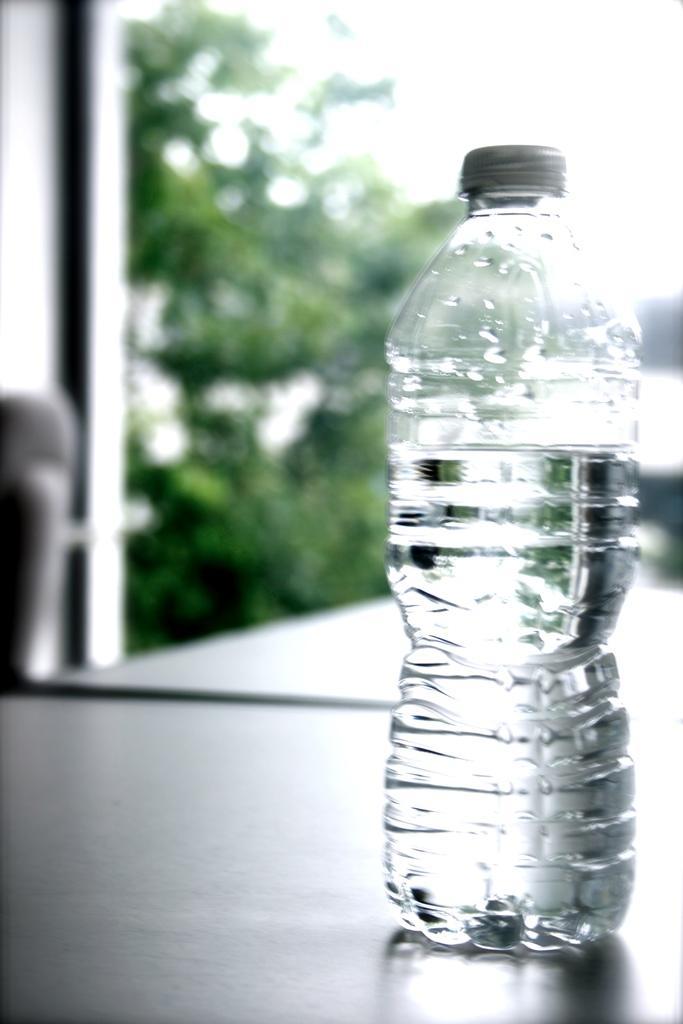In one or two sentences, can you explain what this image depicts? In this there is a bottle filled with liquid in it. At the background there are few trees. 